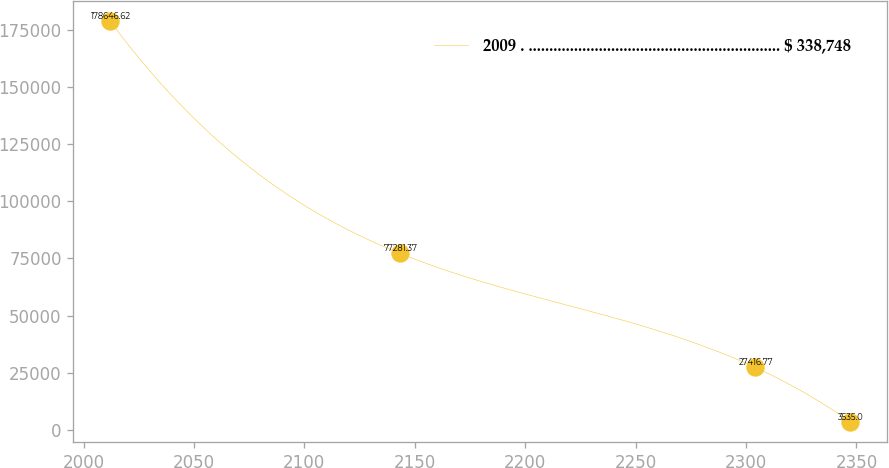Convert chart. <chart><loc_0><loc_0><loc_500><loc_500><line_chart><ecel><fcel>2009 . ............................................................. $ 338,748<nl><fcel>2012.14<fcel>178647<nl><fcel>2143.12<fcel>77281.4<nl><fcel>2304.02<fcel>27416.8<nl><fcel>2347.24<fcel>3535<nl></chart> 